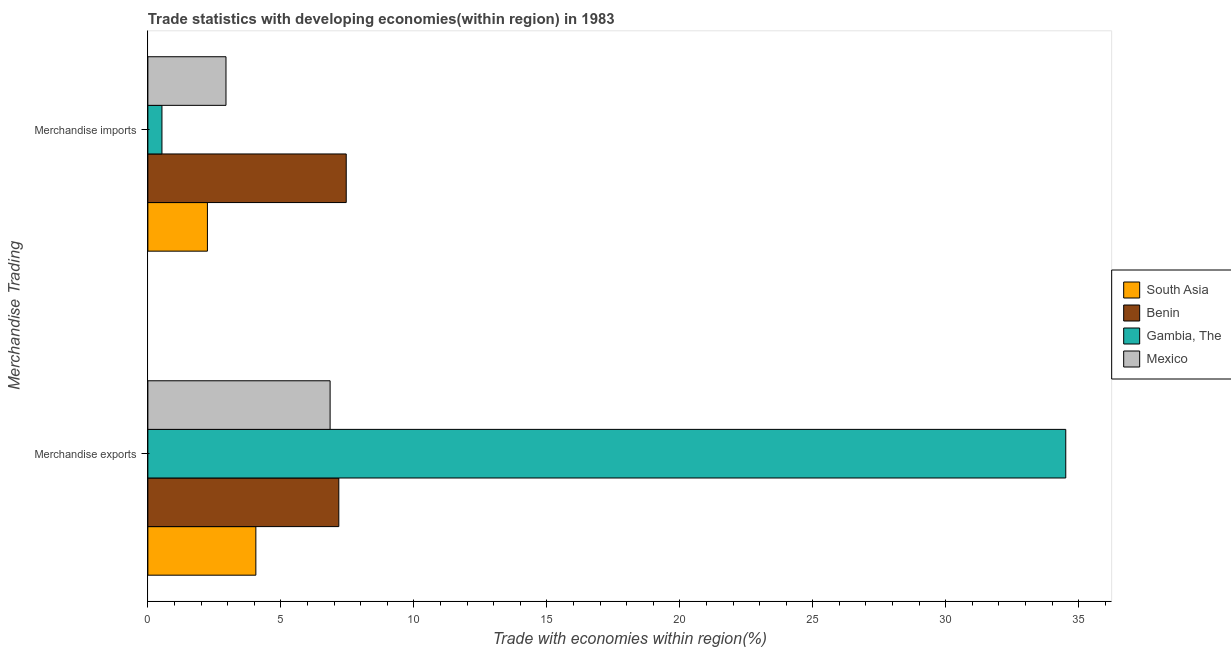Are the number of bars per tick equal to the number of legend labels?
Ensure brevity in your answer.  Yes. How many bars are there on the 1st tick from the top?
Ensure brevity in your answer.  4. What is the label of the 1st group of bars from the top?
Offer a very short reply. Merchandise imports. What is the merchandise exports in Gambia, The?
Your answer should be compact. 34.51. Across all countries, what is the maximum merchandise exports?
Make the answer very short. 34.51. Across all countries, what is the minimum merchandise imports?
Your response must be concise. 0.53. In which country was the merchandise imports maximum?
Provide a succinct answer. Benin. In which country was the merchandise imports minimum?
Make the answer very short. Gambia, The. What is the total merchandise exports in the graph?
Provide a succinct answer. 52.6. What is the difference between the merchandise exports in Mexico and that in Gambia, The?
Give a very brief answer. -27.66. What is the difference between the merchandise exports in Gambia, The and the merchandise imports in Mexico?
Offer a very short reply. 31.57. What is the average merchandise imports per country?
Your response must be concise. 3.29. What is the difference between the merchandise exports and merchandise imports in Gambia, The?
Your answer should be very brief. 33.98. In how many countries, is the merchandise exports greater than 11 %?
Offer a terse response. 1. What is the ratio of the merchandise imports in Gambia, The to that in South Asia?
Make the answer very short. 0.24. What does the 2nd bar from the top in Merchandise imports represents?
Your response must be concise. Gambia, The. What does the 4th bar from the bottom in Merchandise imports represents?
Your answer should be compact. Mexico. Does the graph contain grids?
Ensure brevity in your answer.  No. Where does the legend appear in the graph?
Give a very brief answer. Center right. How many legend labels are there?
Offer a very short reply. 4. How are the legend labels stacked?
Make the answer very short. Vertical. What is the title of the graph?
Your response must be concise. Trade statistics with developing economies(within region) in 1983. Does "Europe(all income levels)" appear as one of the legend labels in the graph?
Your answer should be very brief. No. What is the label or title of the X-axis?
Your answer should be compact. Trade with economies within region(%). What is the label or title of the Y-axis?
Keep it short and to the point. Merchandise Trading. What is the Trade with economies within region(%) in South Asia in Merchandise exports?
Offer a terse response. 4.06. What is the Trade with economies within region(%) in Benin in Merchandise exports?
Give a very brief answer. 7.18. What is the Trade with economies within region(%) in Gambia, The in Merchandise exports?
Provide a short and direct response. 34.51. What is the Trade with economies within region(%) of Mexico in Merchandise exports?
Your response must be concise. 6.85. What is the Trade with economies within region(%) of South Asia in Merchandise imports?
Offer a very short reply. 2.24. What is the Trade with economies within region(%) of Benin in Merchandise imports?
Your response must be concise. 7.46. What is the Trade with economies within region(%) of Gambia, The in Merchandise imports?
Your response must be concise. 0.53. What is the Trade with economies within region(%) in Mexico in Merchandise imports?
Your answer should be compact. 2.94. Across all Merchandise Trading, what is the maximum Trade with economies within region(%) in South Asia?
Your response must be concise. 4.06. Across all Merchandise Trading, what is the maximum Trade with economies within region(%) of Benin?
Your response must be concise. 7.46. Across all Merchandise Trading, what is the maximum Trade with economies within region(%) of Gambia, The?
Offer a very short reply. 34.51. Across all Merchandise Trading, what is the maximum Trade with economies within region(%) in Mexico?
Make the answer very short. 6.85. Across all Merchandise Trading, what is the minimum Trade with economies within region(%) of South Asia?
Keep it short and to the point. 2.24. Across all Merchandise Trading, what is the minimum Trade with economies within region(%) in Benin?
Give a very brief answer. 7.18. Across all Merchandise Trading, what is the minimum Trade with economies within region(%) of Gambia, The?
Provide a short and direct response. 0.53. Across all Merchandise Trading, what is the minimum Trade with economies within region(%) of Mexico?
Your answer should be compact. 2.94. What is the total Trade with economies within region(%) of South Asia in the graph?
Make the answer very short. 6.3. What is the total Trade with economies within region(%) of Benin in the graph?
Make the answer very short. 14.64. What is the total Trade with economies within region(%) in Gambia, The in the graph?
Offer a terse response. 35.04. What is the total Trade with economies within region(%) in Mexico in the graph?
Offer a terse response. 9.79. What is the difference between the Trade with economies within region(%) of South Asia in Merchandise exports and that in Merchandise imports?
Your response must be concise. 1.82. What is the difference between the Trade with economies within region(%) in Benin in Merchandise exports and that in Merchandise imports?
Give a very brief answer. -0.28. What is the difference between the Trade with economies within region(%) of Gambia, The in Merchandise exports and that in Merchandise imports?
Keep it short and to the point. 33.98. What is the difference between the Trade with economies within region(%) in Mexico in Merchandise exports and that in Merchandise imports?
Provide a short and direct response. 3.92. What is the difference between the Trade with economies within region(%) of South Asia in Merchandise exports and the Trade with economies within region(%) of Benin in Merchandise imports?
Keep it short and to the point. -3.4. What is the difference between the Trade with economies within region(%) in South Asia in Merchandise exports and the Trade with economies within region(%) in Gambia, The in Merchandise imports?
Provide a succinct answer. 3.53. What is the difference between the Trade with economies within region(%) of South Asia in Merchandise exports and the Trade with economies within region(%) of Mexico in Merchandise imports?
Offer a terse response. 1.12. What is the difference between the Trade with economies within region(%) of Benin in Merchandise exports and the Trade with economies within region(%) of Gambia, The in Merchandise imports?
Keep it short and to the point. 6.65. What is the difference between the Trade with economies within region(%) in Benin in Merchandise exports and the Trade with economies within region(%) in Mexico in Merchandise imports?
Your answer should be compact. 4.24. What is the difference between the Trade with economies within region(%) of Gambia, The in Merchandise exports and the Trade with economies within region(%) of Mexico in Merchandise imports?
Ensure brevity in your answer.  31.57. What is the average Trade with economies within region(%) in South Asia per Merchandise Trading?
Offer a very short reply. 3.15. What is the average Trade with economies within region(%) in Benin per Merchandise Trading?
Offer a very short reply. 7.32. What is the average Trade with economies within region(%) of Gambia, The per Merchandise Trading?
Your answer should be very brief. 17.52. What is the average Trade with economies within region(%) in Mexico per Merchandise Trading?
Give a very brief answer. 4.89. What is the difference between the Trade with economies within region(%) in South Asia and Trade with economies within region(%) in Benin in Merchandise exports?
Make the answer very short. -3.12. What is the difference between the Trade with economies within region(%) of South Asia and Trade with economies within region(%) of Gambia, The in Merchandise exports?
Your answer should be very brief. -30.45. What is the difference between the Trade with economies within region(%) in South Asia and Trade with economies within region(%) in Mexico in Merchandise exports?
Your answer should be very brief. -2.79. What is the difference between the Trade with economies within region(%) of Benin and Trade with economies within region(%) of Gambia, The in Merchandise exports?
Provide a short and direct response. -27.33. What is the difference between the Trade with economies within region(%) of Benin and Trade with economies within region(%) of Mexico in Merchandise exports?
Your response must be concise. 0.33. What is the difference between the Trade with economies within region(%) of Gambia, The and Trade with economies within region(%) of Mexico in Merchandise exports?
Offer a terse response. 27.66. What is the difference between the Trade with economies within region(%) in South Asia and Trade with economies within region(%) in Benin in Merchandise imports?
Your response must be concise. -5.22. What is the difference between the Trade with economies within region(%) of South Asia and Trade with economies within region(%) of Gambia, The in Merchandise imports?
Provide a succinct answer. 1.71. What is the difference between the Trade with economies within region(%) in South Asia and Trade with economies within region(%) in Mexico in Merchandise imports?
Offer a very short reply. -0.7. What is the difference between the Trade with economies within region(%) in Benin and Trade with economies within region(%) in Gambia, The in Merchandise imports?
Keep it short and to the point. 6.93. What is the difference between the Trade with economies within region(%) in Benin and Trade with economies within region(%) in Mexico in Merchandise imports?
Make the answer very short. 4.52. What is the difference between the Trade with economies within region(%) of Gambia, The and Trade with economies within region(%) of Mexico in Merchandise imports?
Ensure brevity in your answer.  -2.41. What is the ratio of the Trade with economies within region(%) in South Asia in Merchandise exports to that in Merchandise imports?
Provide a succinct answer. 1.81. What is the ratio of the Trade with economies within region(%) in Benin in Merchandise exports to that in Merchandise imports?
Your answer should be compact. 0.96. What is the ratio of the Trade with economies within region(%) in Gambia, The in Merchandise exports to that in Merchandise imports?
Provide a succinct answer. 65.13. What is the ratio of the Trade with economies within region(%) in Mexico in Merchandise exports to that in Merchandise imports?
Provide a short and direct response. 2.33. What is the difference between the highest and the second highest Trade with economies within region(%) of South Asia?
Your answer should be very brief. 1.82. What is the difference between the highest and the second highest Trade with economies within region(%) in Benin?
Your answer should be compact. 0.28. What is the difference between the highest and the second highest Trade with economies within region(%) of Gambia, The?
Offer a terse response. 33.98. What is the difference between the highest and the second highest Trade with economies within region(%) in Mexico?
Make the answer very short. 3.92. What is the difference between the highest and the lowest Trade with economies within region(%) in South Asia?
Keep it short and to the point. 1.82. What is the difference between the highest and the lowest Trade with economies within region(%) in Benin?
Provide a short and direct response. 0.28. What is the difference between the highest and the lowest Trade with economies within region(%) of Gambia, The?
Ensure brevity in your answer.  33.98. What is the difference between the highest and the lowest Trade with economies within region(%) in Mexico?
Ensure brevity in your answer.  3.92. 